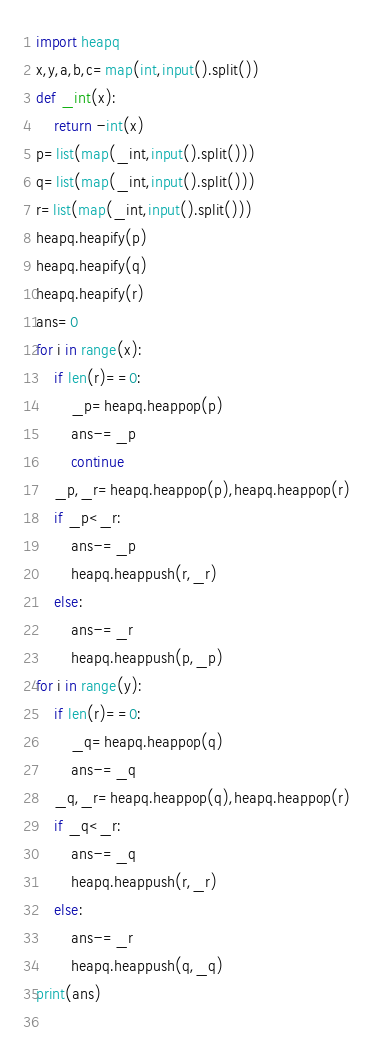<code> <loc_0><loc_0><loc_500><loc_500><_Python_>import heapq
x,y,a,b,c=map(int,input().split())
def _int(x):
    return -int(x)
p=list(map(_int,input().split()))
q=list(map(_int,input().split()))
r=list(map(_int,input().split()))
heapq.heapify(p)
heapq.heapify(q)
heapq.heapify(r)
ans=0
for i in range(x):
    if len(r)==0:
        _p=heapq.heappop(p)
        ans-=_p
        continue
    _p,_r=heapq.heappop(p),heapq.heappop(r)
    if _p<_r:
        ans-=_p
        heapq.heappush(r,_r)
    else:
        ans-=_r
        heapq.heappush(p,_p)
for i in range(y):
    if len(r)==0:
        _q=heapq.heappop(q)
        ans-=_q
    _q,_r=heapq.heappop(q),heapq.heappop(r)
    if _q<_r:
        ans-=_q
        heapq.heappush(r,_r)
    else:
        ans-=_r
        heapq.heappush(q,_q)
print(ans)
    
</code> 